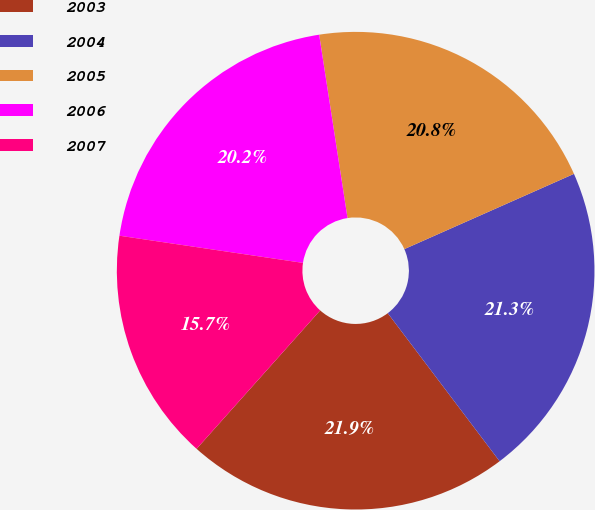<chart> <loc_0><loc_0><loc_500><loc_500><pie_chart><fcel>2003<fcel>2004<fcel>2005<fcel>2006<fcel>2007<nl><fcel>21.9%<fcel>21.35%<fcel>20.8%<fcel>20.22%<fcel>15.74%<nl></chart> 